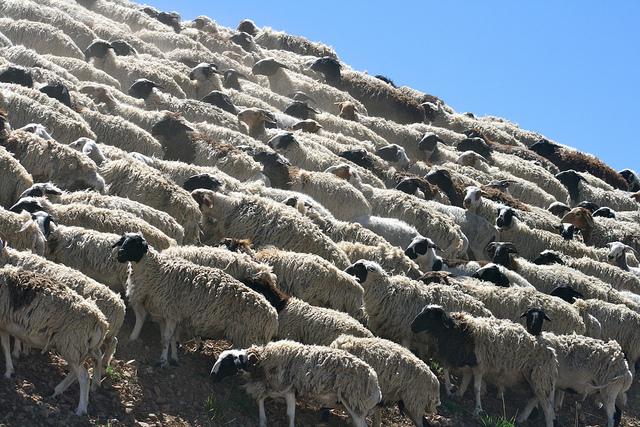What is this group called?
Quick response, please. Herd. Do you think there is more than 10 sheep?
Answer briefly. Yes. Where are all the sheep going?
Quick response, please. Uphill. What color are the animals?
Keep it brief. White. 